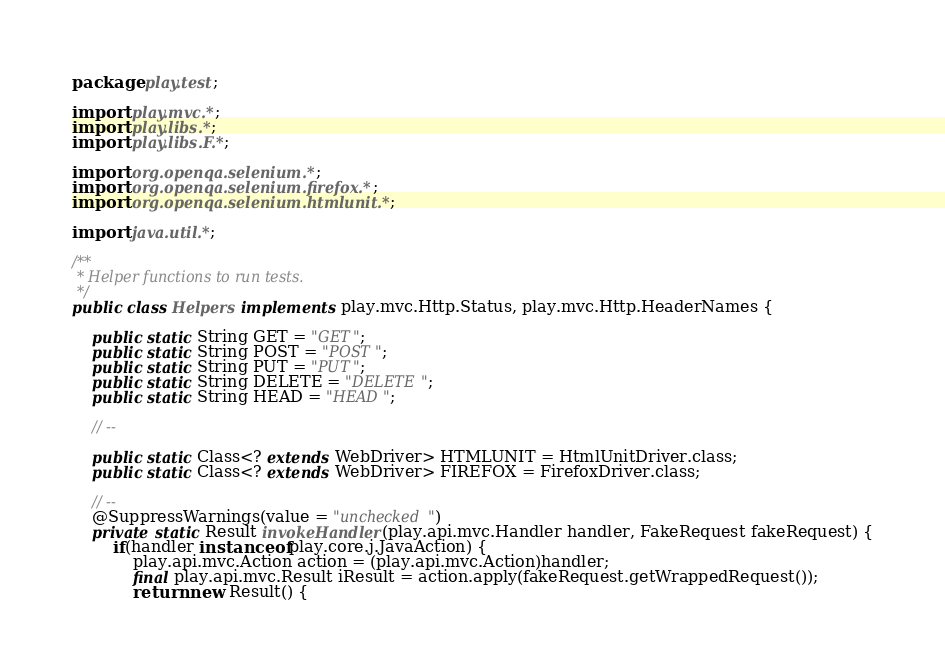<code> <loc_0><loc_0><loc_500><loc_500><_Java_>package play.test;

import play.mvc.*;
import play.libs.*;
import play.libs.F.*;

import org.openqa.selenium.*;
import org.openqa.selenium.firefox.*;
import org.openqa.selenium.htmlunit.*;

import java.util.*;

/**
 * Helper functions to run tests.
 */
public class Helpers implements play.mvc.Http.Status, play.mvc.Http.HeaderNames {

    public static String GET = "GET";
    public static String POST = "POST";
    public static String PUT = "PUT";
    public static String DELETE = "DELETE";
    public static String HEAD = "HEAD";

    // --
    
    public static Class<? extends WebDriver> HTMLUNIT = HtmlUnitDriver.class;
    public static Class<? extends WebDriver> FIREFOX = FirefoxDriver.class;

    // --
    @SuppressWarnings(value = "unchecked")
    private static Result invokeHandler(play.api.mvc.Handler handler, FakeRequest fakeRequest) {
        if(handler instanceof play.core.j.JavaAction) {
            play.api.mvc.Action action = (play.api.mvc.Action)handler;
            final play.api.mvc.Result iResult = action.apply(fakeRequest.getWrappedRequest());
            return new Result() {
</code> 